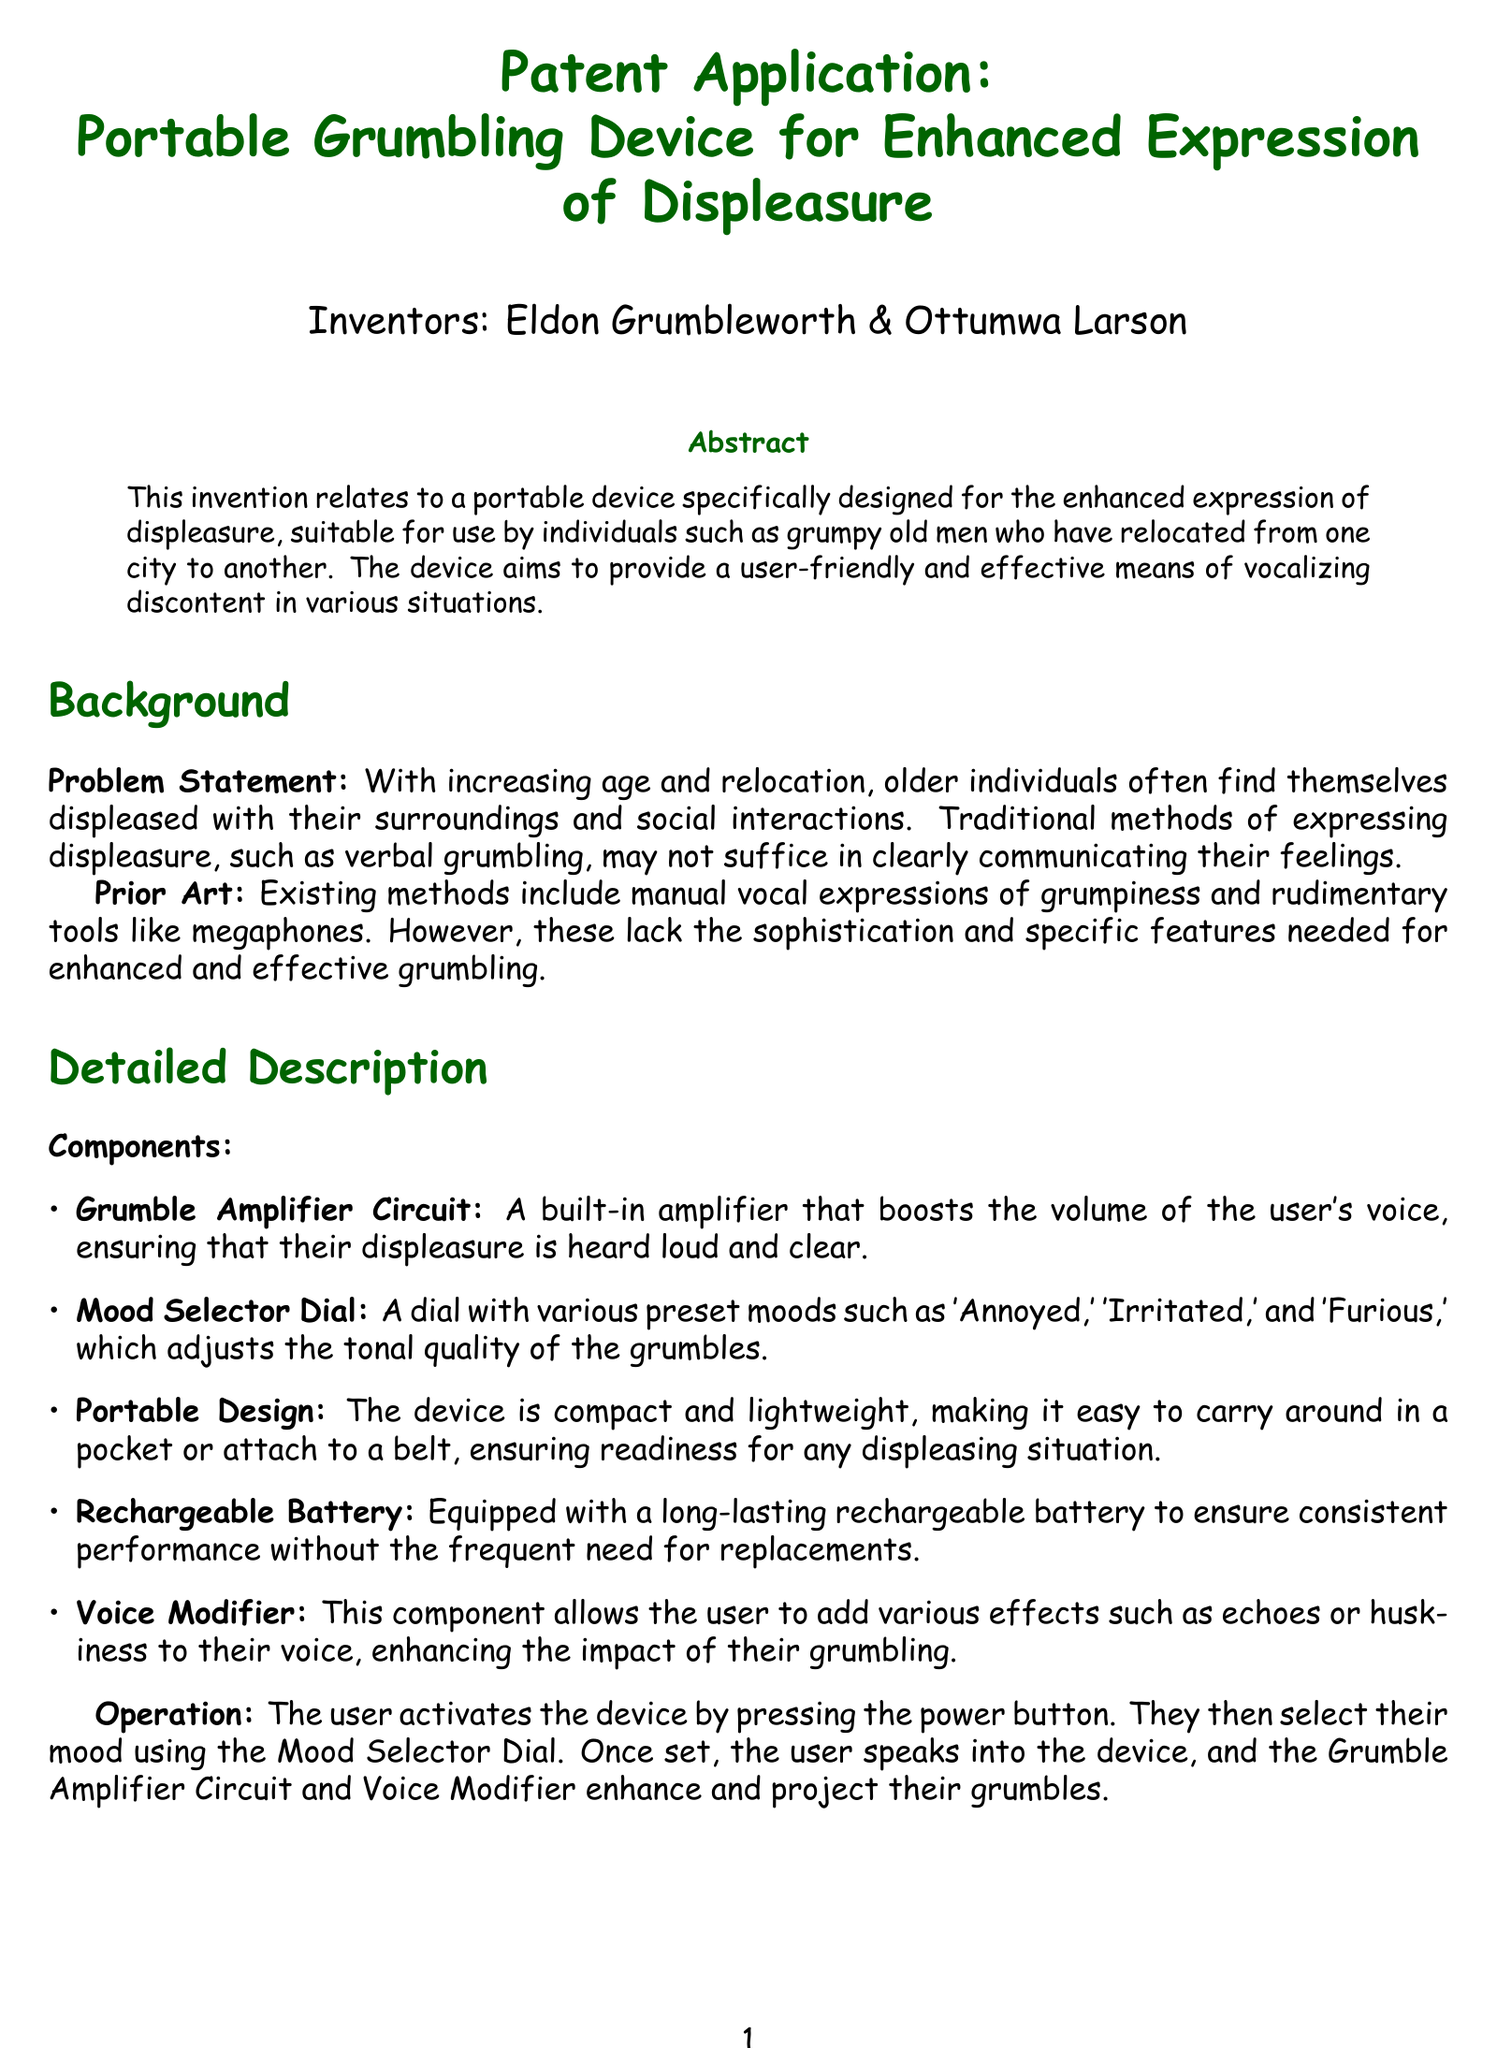What is the title of the patent application? The title is stated at the beginning of the document under the title section.
Answer: Portable Grumbling Device for Enhanced Expression of Displeasure Who are the inventors of the device? The inventors are listed in the author section of the document.
Answer: Eldon Grumbleworth & Ottumwa Larson What does the Mood Selector Dial include? The document mentions the presets included in the Mood Selector Dial under the detailed description section.
Answer: 'Annoyed,' 'Irritated,' and 'Furious' What component amplifies the user's voice? This information is provided in the detailed description section discussing the components of the device.
Answer: Grumble Amplifier Circuit How many claims are made in the patent application? The number of claims is stated in the claims section of the document.
Answer: Five What is the primary purpose of the device? The primary purpose is outlined in the abstract section of the document.
Answer: Enhanced expression of displeasure What type of battery does the device use? The type of battery is mentioned in the detailed description of components of the device.
Answer: Rechargeable battery What is the mood that does not appear as a preset in the Mood Selector Dial? This requires reasoning about the listed moods in the detailed description.
Answer: Happy 